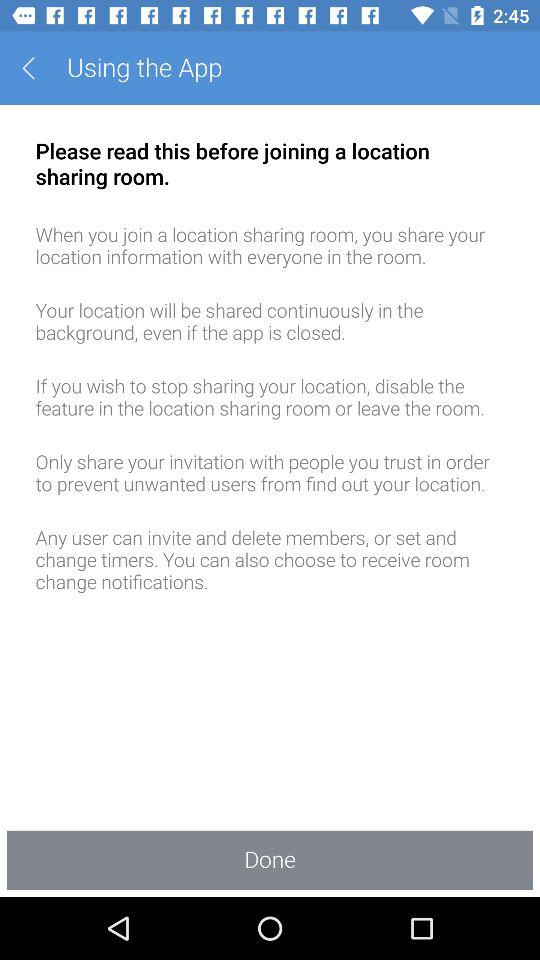How can the sharing location be stopped? The sharing location was stopped by "disable the feature in the location sharing room or leave the room". 